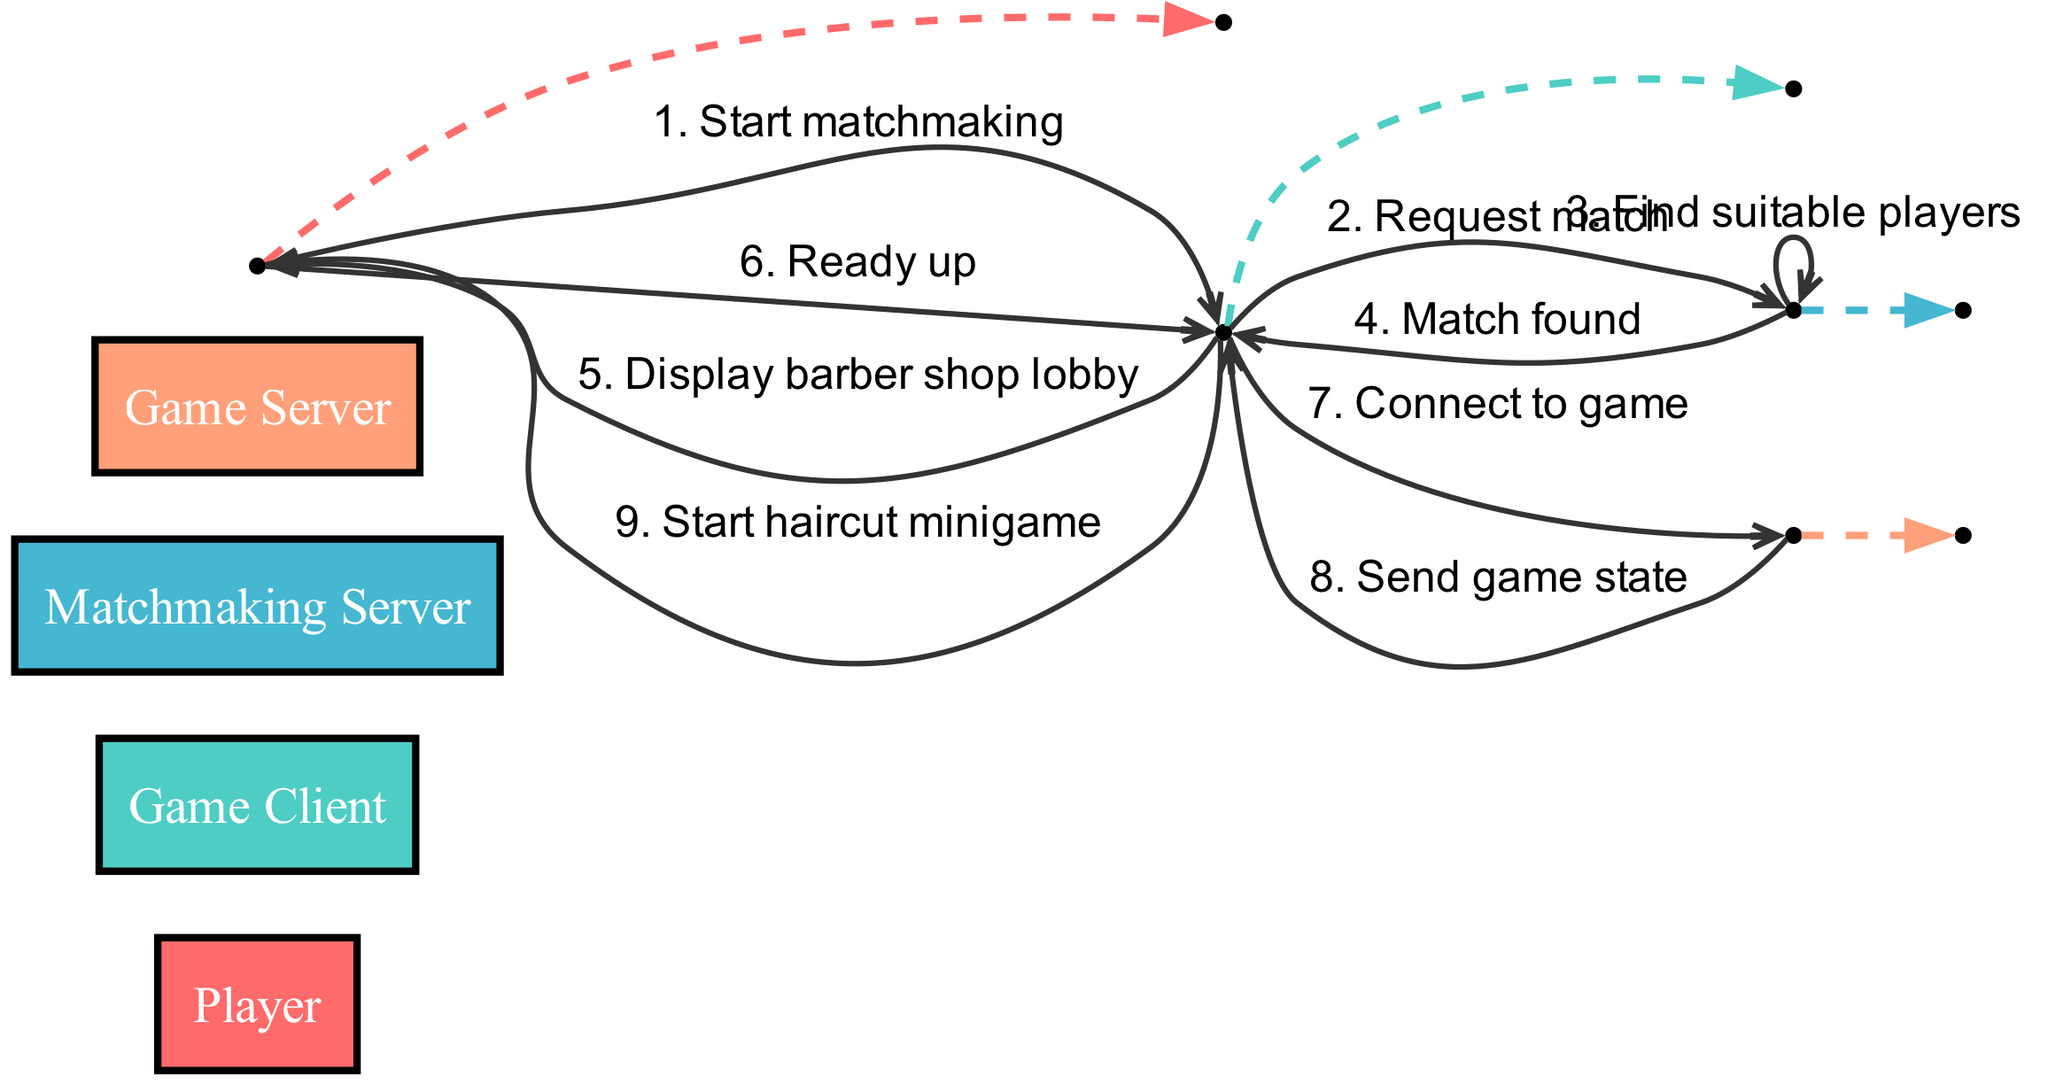What is the first action taken by the Player? The sequence starts with the Player initiating the process by sending the message "Start matchmaking" to the Game Client.
Answer: Start matchmaking How many actors are involved in the sequence? The diagram lists four actors: Player, Game Client, Matchmaking Server, and Game Server. Therefore, there are four parties involved in the sequence.
Answer: 4 What message does the Matchmaking Server send to the Game Client? After finding suitable players, the Matchmaking Server communicates to the Game Client with the message "Match found." This is a critical point indicating a successful match.
Answer: Match found Which actor is responsible for connecting to the game server? The Game Client is responsible for this action, as it sends the message "Connect to game" to the Game Server, establishing the connection to commence gameplay.
Answer: Game Client What does the Player do after the Game Client displays the barber shop lobby? The Player's next action is to communicate readiness to the Game Client by sending the message "Ready up," indicating they are prepared to start the game.
Answer: Ready up How many messages are exchanged between the Game Client and the Matchmaking Server? The sequence indicates two messages exchanged directly: one request from the Game Client to the Matchmaking Server and the subsequent response when a match is found. Therefore, the total count is two.
Answer: 2 What is the final action that occurs in the sequence? The last step indicated in the sequence is the Game Client sending the message "Start haircut minigame" to the Player, thus initiating the gameplay phase after connection and readiness.
Answer: Start haircut minigame Which actor sends the game state back to the Game Client? The Game Server is the actor that sends the game state back, as it provides the necessary information for the Game Client to proceed with the game.
Answer: Game Server What step follows the "Ready up" action in the sequence? Following the "Ready up" message from the Player, the next step is for the Game Client to send a connection request to the Game Server by delivering the message "Connect to game."
Answer: Connect to game 